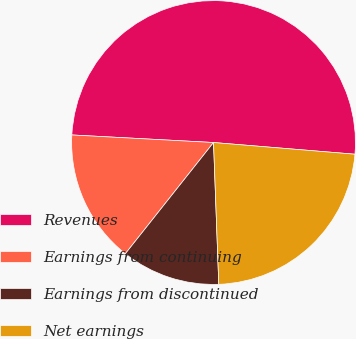Convert chart to OTSL. <chart><loc_0><loc_0><loc_500><loc_500><pie_chart><fcel>Revenues<fcel>Earnings from continuing<fcel>Earnings from discontinued<fcel>Net earnings<nl><fcel>50.47%<fcel>15.18%<fcel>11.26%<fcel>23.1%<nl></chart> 